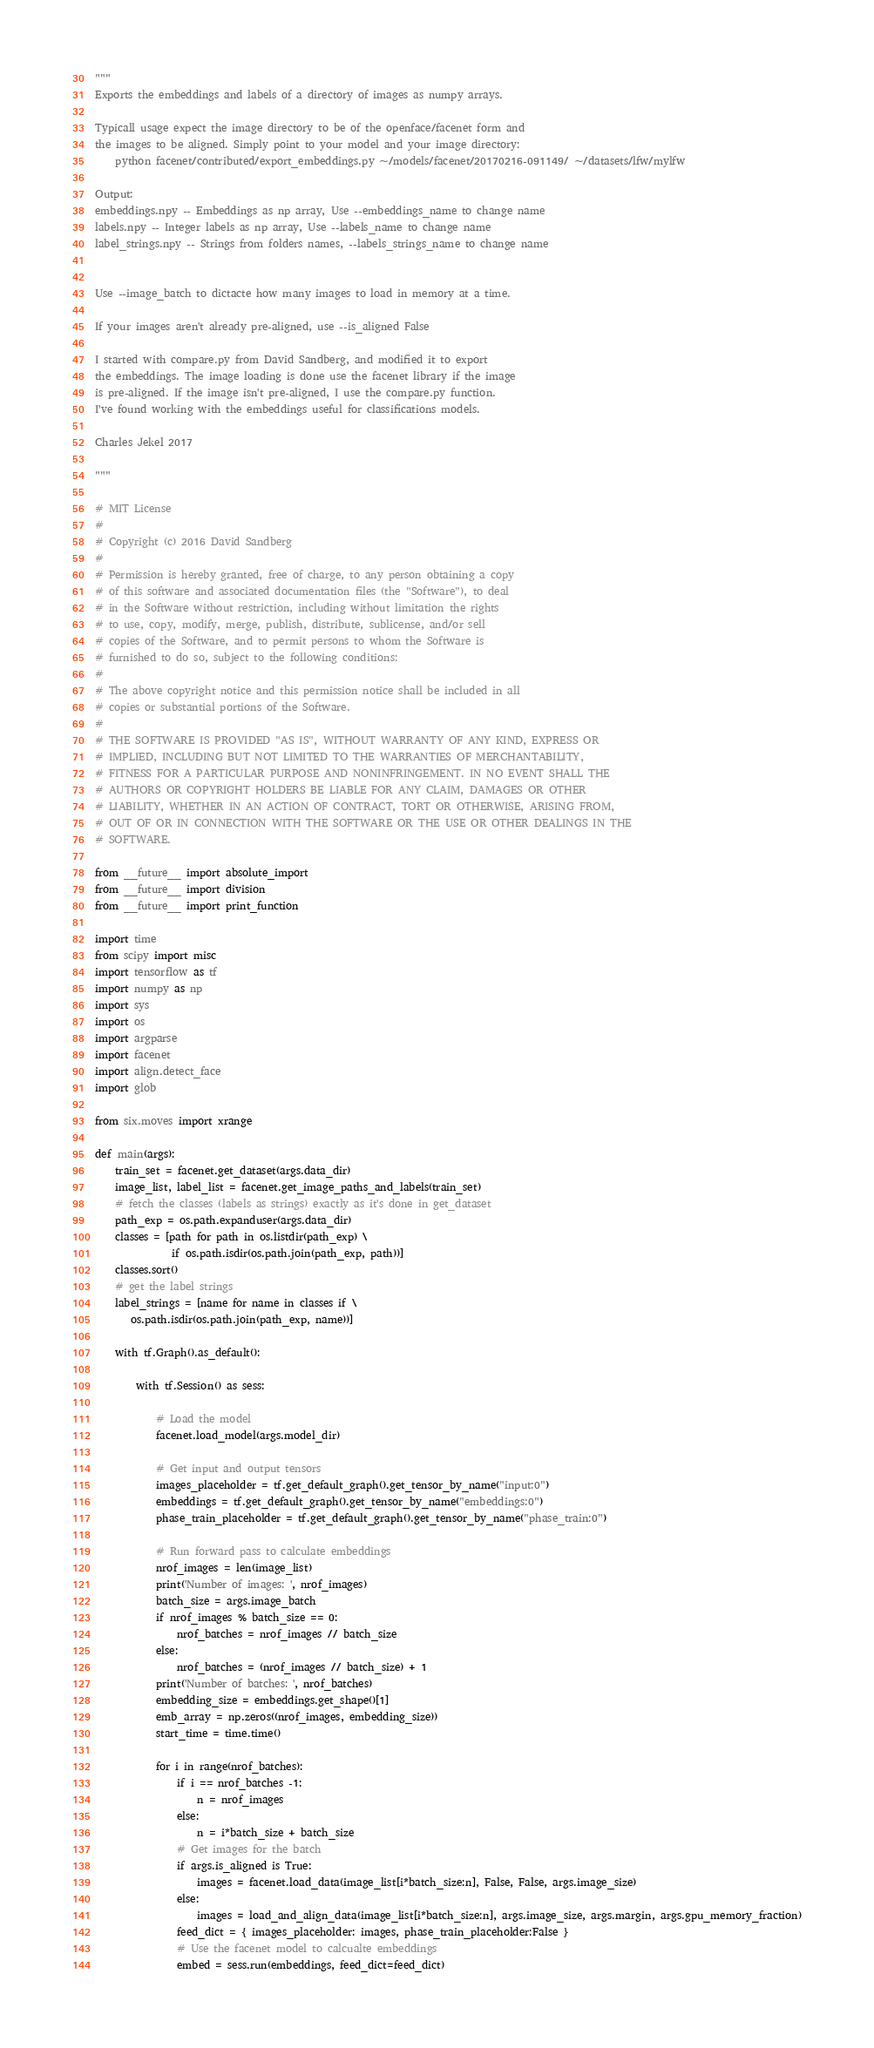<code> <loc_0><loc_0><loc_500><loc_500><_Python_>"""
Exports the embeddings and labels of a directory of images as numpy arrays.

Typicall usage expect the image directory to be of the openface/facenet form and
the images to be aligned. Simply point to your model and your image directory:
    python facenet/contributed/export_embeddings.py ~/models/facenet/20170216-091149/ ~/datasets/lfw/mylfw

Output:
embeddings.npy -- Embeddings as np array, Use --embeddings_name to change name
labels.npy -- Integer labels as np array, Use --labels_name to change name
label_strings.npy -- Strings from folders names, --labels_strings_name to change name


Use --image_batch to dictacte how many images to load in memory at a time.

If your images aren't already pre-aligned, use --is_aligned False

I started with compare.py from David Sandberg, and modified it to export
the embeddings. The image loading is done use the facenet library if the image
is pre-aligned. If the image isn't pre-aligned, I use the compare.py function.
I've found working with the embeddings useful for classifications models.

Charles Jekel 2017

"""

# MIT License
#
# Copyright (c) 2016 David Sandberg
#
# Permission is hereby granted, free of charge, to any person obtaining a copy
# of this software and associated documentation files (the "Software"), to deal
# in the Software without restriction, including without limitation the rights
# to use, copy, modify, merge, publish, distribute, sublicense, and/or sell
# copies of the Software, and to permit persons to whom the Software is
# furnished to do so, subject to the following conditions:
#
# The above copyright notice and this permission notice shall be included in all
# copies or substantial portions of the Software.
#
# THE SOFTWARE IS PROVIDED "AS IS", WITHOUT WARRANTY OF ANY KIND, EXPRESS OR
# IMPLIED, INCLUDING BUT NOT LIMITED TO THE WARRANTIES OF MERCHANTABILITY,
# FITNESS FOR A PARTICULAR PURPOSE AND NONINFRINGEMENT. IN NO EVENT SHALL THE
# AUTHORS OR COPYRIGHT HOLDERS BE LIABLE FOR ANY CLAIM, DAMAGES OR OTHER
# LIABILITY, WHETHER IN AN ACTION OF CONTRACT, TORT OR OTHERWISE, ARISING FROM,
# OUT OF OR IN CONNECTION WITH THE SOFTWARE OR THE USE OR OTHER DEALINGS IN THE
# SOFTWARE.

from __future__ import absolute_import
from __future__ import division
from __future__ import print_function

import time
from scipy import misc
import tensorflow as tf
import numpy as np
import sys
import os
import argparse
import facenet
import align.detect_face
import glob

from six.moves import xrange

def main(args):
    train_set = facenet.get_dataset(args.data_dir)
    image_list, label_list = facenet.get_image_paths_and_labels(train_set)
    # fetch the classes (labels as strings) exactly as it's done in get_dataset
    path_exp = os.path.expanduser(args.data_dir)
    classes = [path for path in os.listdir(path_exp) \
               if os.path.isdir(os.path.join(path_exp, path))]
    classes.sort()
    # get the label strings
    label_strings = [name for name in classes if \
       os.path.isdir(os.path.join(path_exp, name))]

    with tf.Graph().as_default():

        with tf.Session() as sess:

            # Load the model
            facenet.load_model(args.model_dir)

            # Get input and output tensors
            images_placeholder = tf.get_default_graph().get_tensor_by_name("input:0")
            embeddings = tf.get_default_graph().get_tensor_by_name("embeddings:0")
            phase_train_placeholder = tf.get_default_graph().get_tensor_by_name("phase_train:0")

            # Run forward pass to calculate embeddings
            nrof_images = len(image_list)
            print('Number of images: ', nrof_images)
            batch_size = args.image_batch
            if nrof_images % batch_size == 0:
                nrof_batches = nrof_images // batch_size
            else:
                nrof_batches = (nrof_images // batch_size) + 1
            print('Number of batches: ', nrof_batches)
            embedding_size = embeddings.get_shape()[1]
            emb_array = np.zeros((nrof_images, embedding_size))
            start_time = time.time()

            for i in range(nrof_batches):
                if i == nrof_batches -1:
                    n = nrof_images
                else:
                    n = i*batch_size + batch_size
                # Get images for the batch
                if args.is_aligned is True:
                    images = facenet.load_data(image_list[i*batch_size:n], False, False, args.image_size)
                else:
                    images = load_and_align_data(image_list[i*batch_size:n], args.image_size, args.margin, args.gpu_memory_fraction)
                feed_dict = { images_placeholder: images, phase_train_placeholder:False }
                # Use the facenet model to calcualte embeddings
                embed = sess.run(embeddings, feed_dict=feed_dict)</code> 